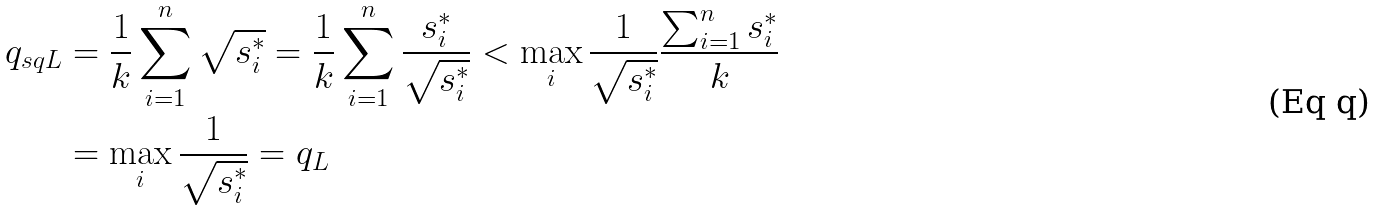Convert formula to latex. <formula><loc_0><loc_0><loc_500><loc_500>q _ { s q L } & = \frac { 1 } { k } \sum _ { i = 1 } ^ { n } \sqrt { s _ { i } ^ { * } } = \frac { 1 } { k } \sum _ { i = 1 } ^ { n } \frac { s _ { i } ^ { * } } { \sqrt { s _ { i } ^ { * } } } < \max _ { i } \frac { 1 } { \sqrt { s _ { i } ^ { * } } } \frac { \sum _ { i = 1 } ^ { n } s _ { i } ^ { * } } { k } \\ & = \max _ { i } \frac { 1 } { \sqrt { s _ { i } ^ { * } } } = q _ { L }</formula> 